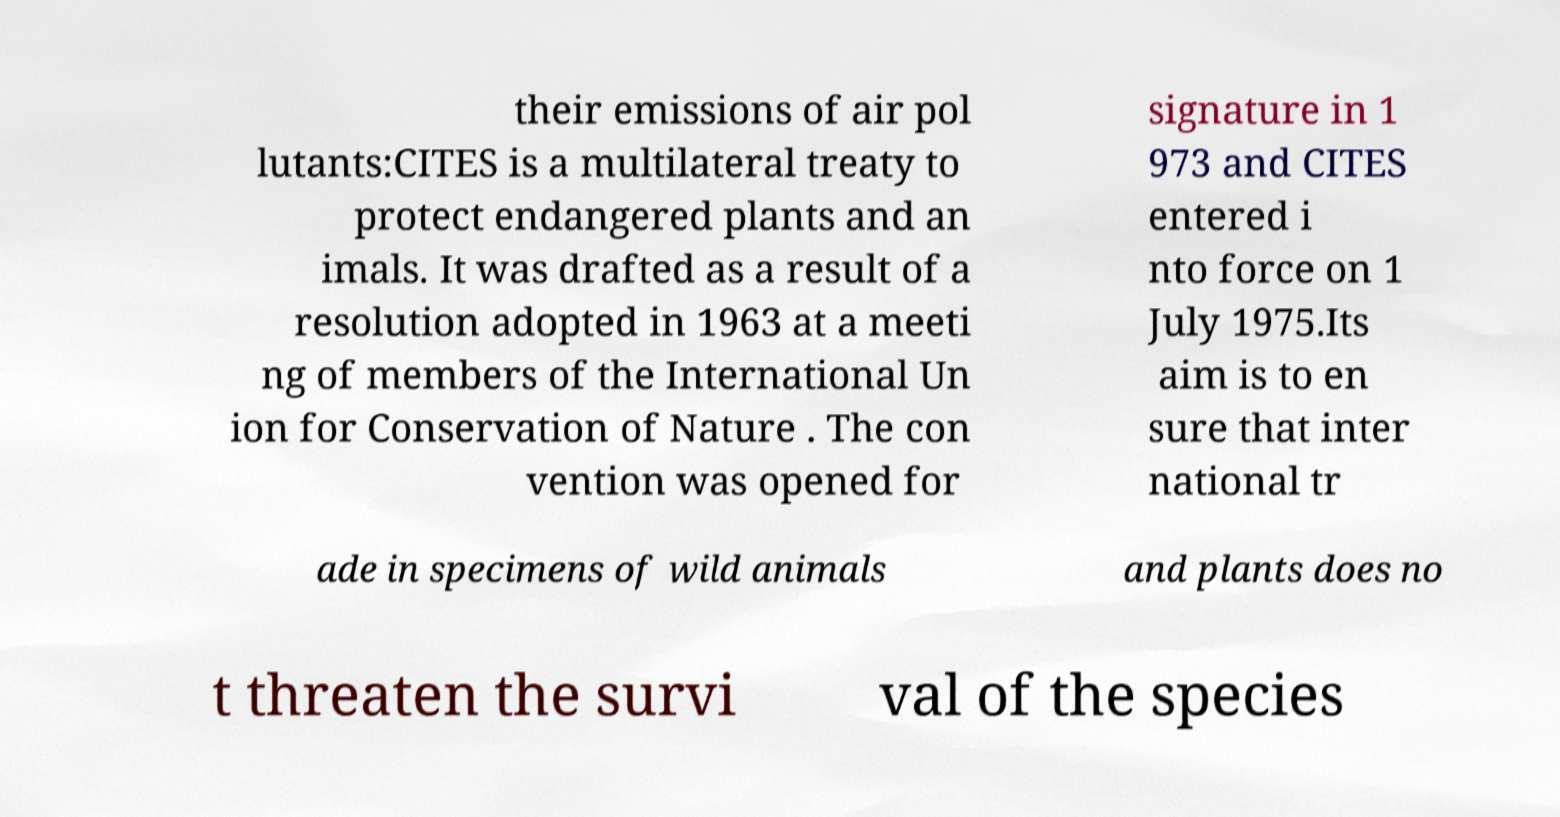Could you extract and type out the text from this image? their emissions of air pol lutants:CITES is a multilateral treaty to protect endangered plants and an imals. It was drafted as a result of a resolution adopted in 1963 at a meeti ng of members of the International Un ion for Conservation of Nature . The con vention was opened for signature in 1 973 and CITES entered i nto force on 1 July 1975.Its aim is to en sure that inter national tr ade in specimens of wild animals and plants does no t threaten the survi val of the species 